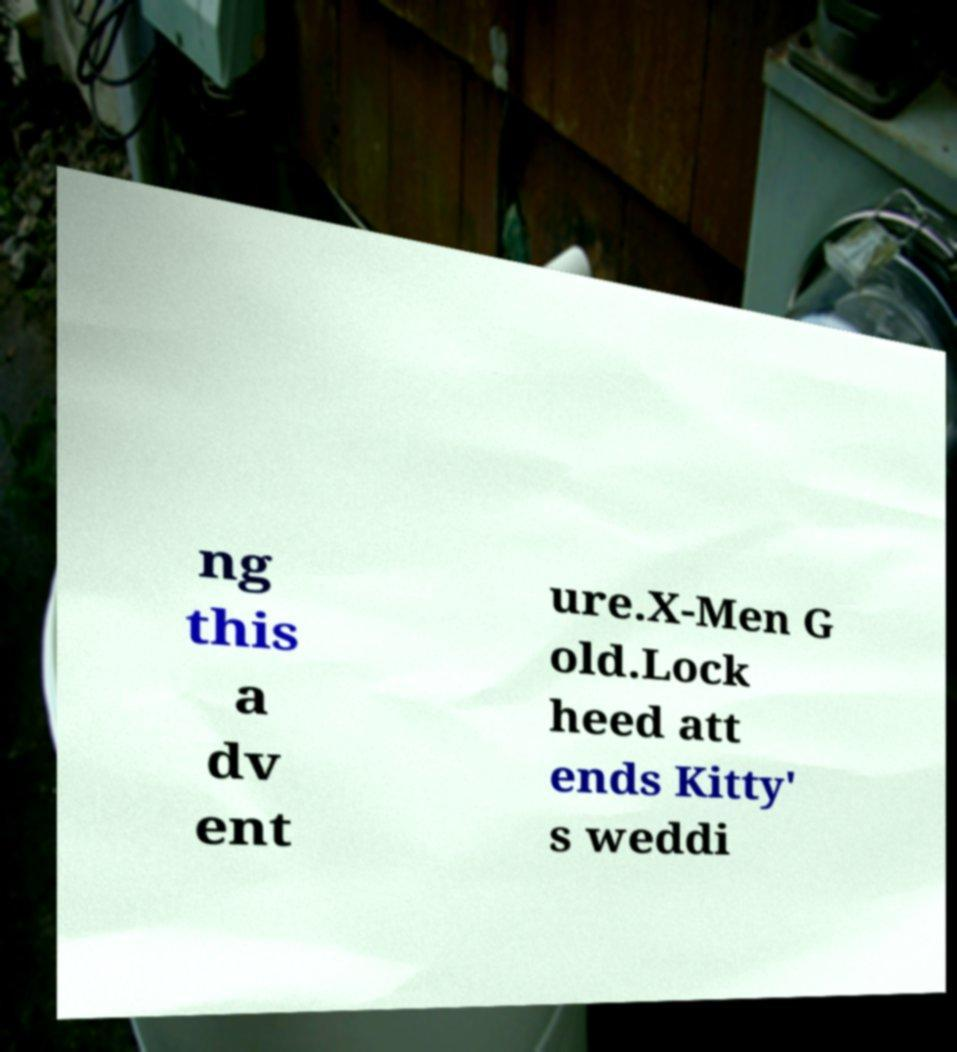Can you accurately transcribe the text from the provided image for me? ng this a dv ent ure.X-Men G old.Lock heed att ends Kitty' s weddi 